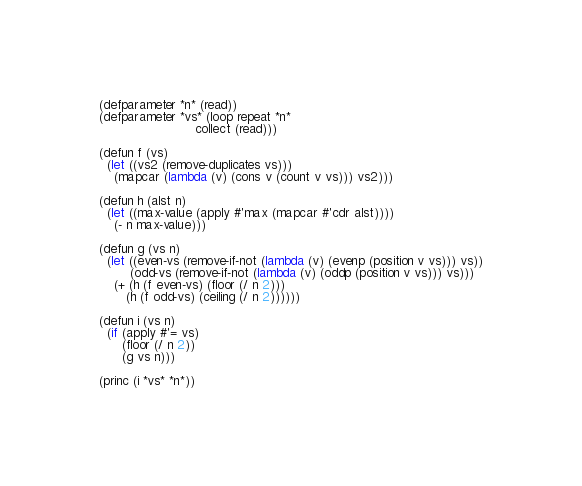Convert code to text. <code><loc_0><loc_0><loc_500><loc_500><_Lisp_>(defparameter *n* (read))
(defparameter *vs* (loop repeat *n*
                         collect (read)))

(defun f (vs)
  (let ((vs2 (remove-duplicates vs)))
    (mapcar (lambda (v) (cons v (count v vs))) vs2)))

(defun h (alst n)
  (let ((max-value (apply #'max (mapcar #'cdr alst))))
    (- n max-value)))

(defun g (vs n)
  (let ((even-vs (remove-if-not (lambda (v) (evenp (position v vs))) vs))
        (odd-vs (remove-if-not (lambda (v) (oddp (position v vs))) vs)))
    (+ (h (f even-vs) (floor (/ n 2)))
       (h (f odd-vs) (ceiling (/ n 2))))))

(defun i (vs n)
  (if (apply #'= vs)
      (floor (/ n 2))
      (g vs n)))

(princ (i *vs* *n*))</code> 